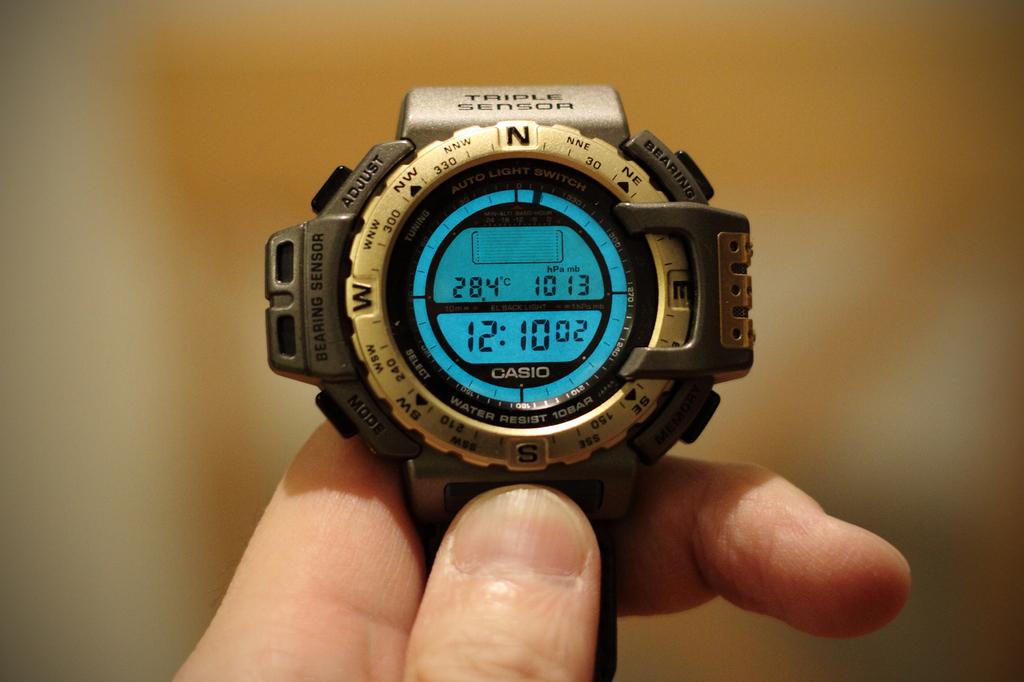What time is it?
Your answer should be very brief. 12:10. What brand of watch?
Ensure brevity in your answer.  Casio. 